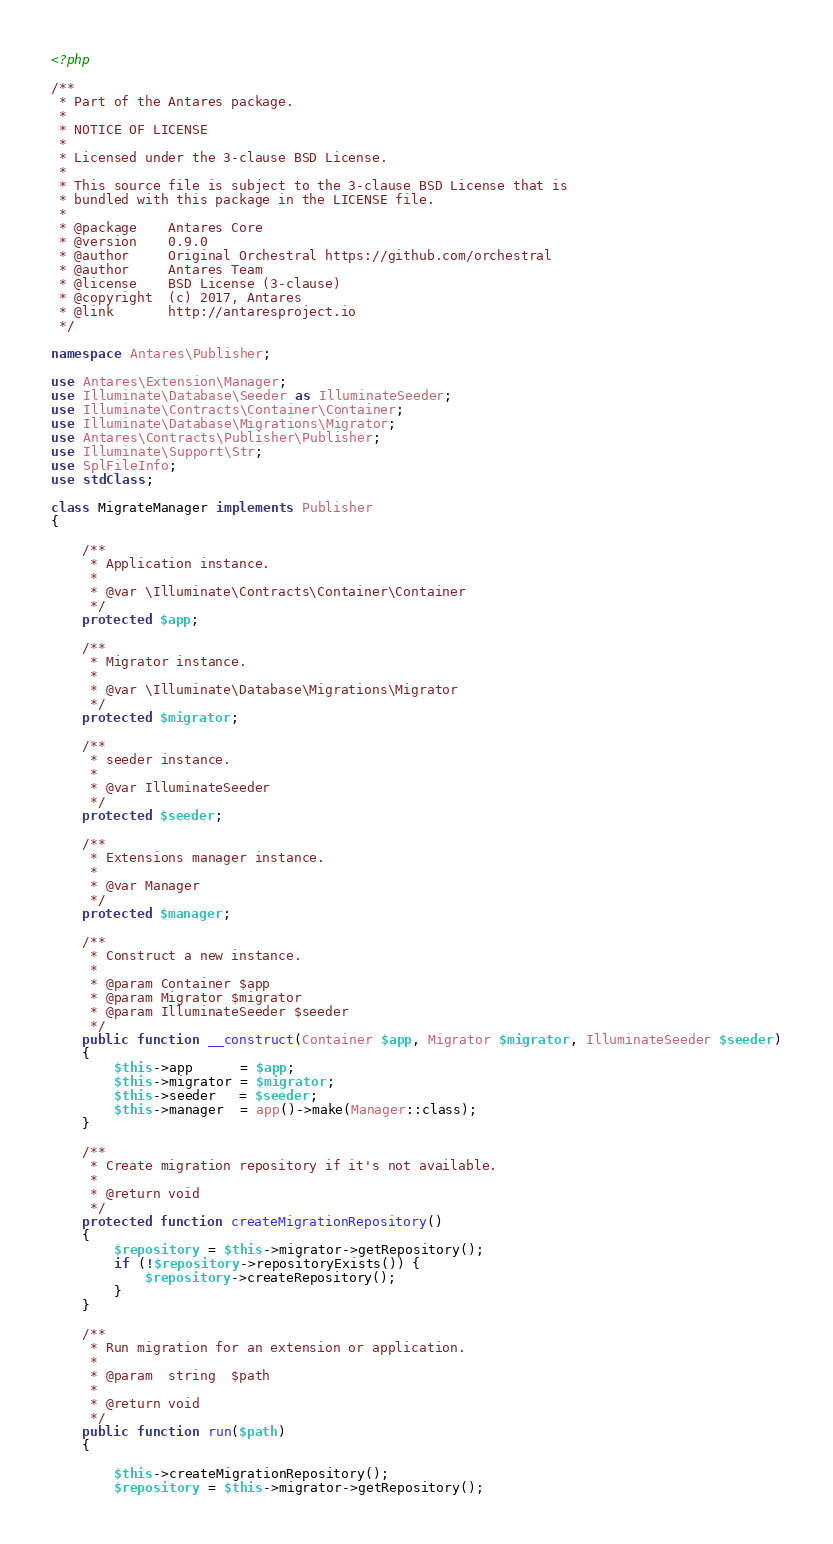Convert code to text. <code><loc_0><loc_0><loc_500><loc_500><_PHP_><?php

/**
 * Part of the Antares package.
 *
 * NOTICE OF LICENSE
 *
 * Licensed under the 3-clause BSD License.
 *
 * This source file is subject to the 3-clause BSD License that is
 * bundled with this package in the LICENSE file.
 *
 * @package    Antares Core
 * @version    0.9.0
 * @author     Original Orchestral https://github.com/orchestral
 * @author     Antares Team
 * @license    BSD License (3-clause)
 * @copyright  (c) 2017, Antares
 * @link       http://antaresproject.io
 */

namespace Antares\Publisher;

use Antares\Extension\Manager;
use Illuminate\Database\Seeder as IlluminateSeeder;
use Illuminate\Contracts\Container\Container;
use Illuminate\Database\Migrations\Migrator;
use Antares\Contracts\Publisher\Publisher;
use Illuminate\Support\Str;
use SplFileInfo;
use stdClass;

class MigrateManager implements Publisher
{

    /**
     * Application instance.
     *
     * @var \Illuminate\Contracts\Container\Container
     */
    protected $app;

    /**
     * Migrator instance.
     *
     * @var \Illuminate\Database\Migrations\Migrator
     */
    protected $migrator;

    /**
     * seeder instance.
     *
     * @var IlluminateSeeder
     */
    protected $seeder;

    /**
     * Extensions manager instance.
     *
     * @var Manager
     */
    protected $manager;

    /**
     * Construct a new instance.
     * 
     * @param Container $app
     * @param Migrator $migrator
     * @param IlluminateSeeder $seeder
     */
    public function __construct(Container $app, Migrator $migrator, IlluminateSeeder $seeder)
    {
        $this->app      = $app;
        $this->migrator = $migrator;
        $this->seeder   = $seeder;
        $this->manager  = app()->make(Manager::class);
    }

    /**
     * Create migration repository if it's not available.
     *
     * @return void
     */
    protected function createMigrationRepository()
    {
        $repository = $this->migrator->getRepository();
        if (!$repository->repositoryExists()) {
            $repository->createRepository();
        }
    }

    /**
     * Run migration for an extension or application.
     *
     * @param  string  $path
     *
     * @return void
     */
    public function run($path)
    {

        $this->createMigrationRepository();
        $repository = $this->migrator->getRepository();</code> 